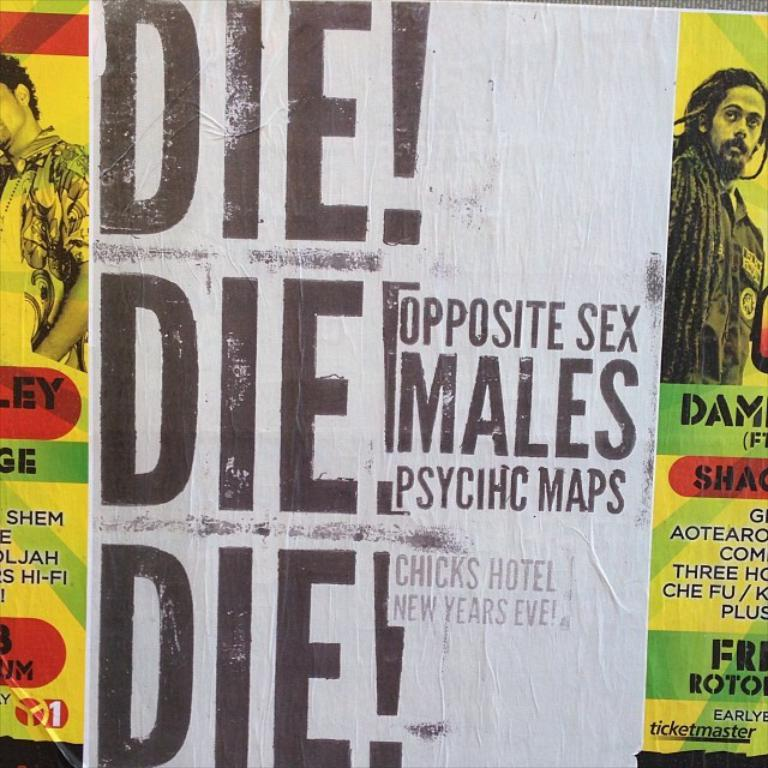What can be seen in the background of the image? There is a wall in the image. What is on the wall? There are posters pasted on the wall. What type of receipt is visible on the wall in the image? There is no receipt visible on the wall in the image; only posters are present. What committee is responsible for the posters on the wall in the image? There is no information about a committee responsible for the posters in the image. 